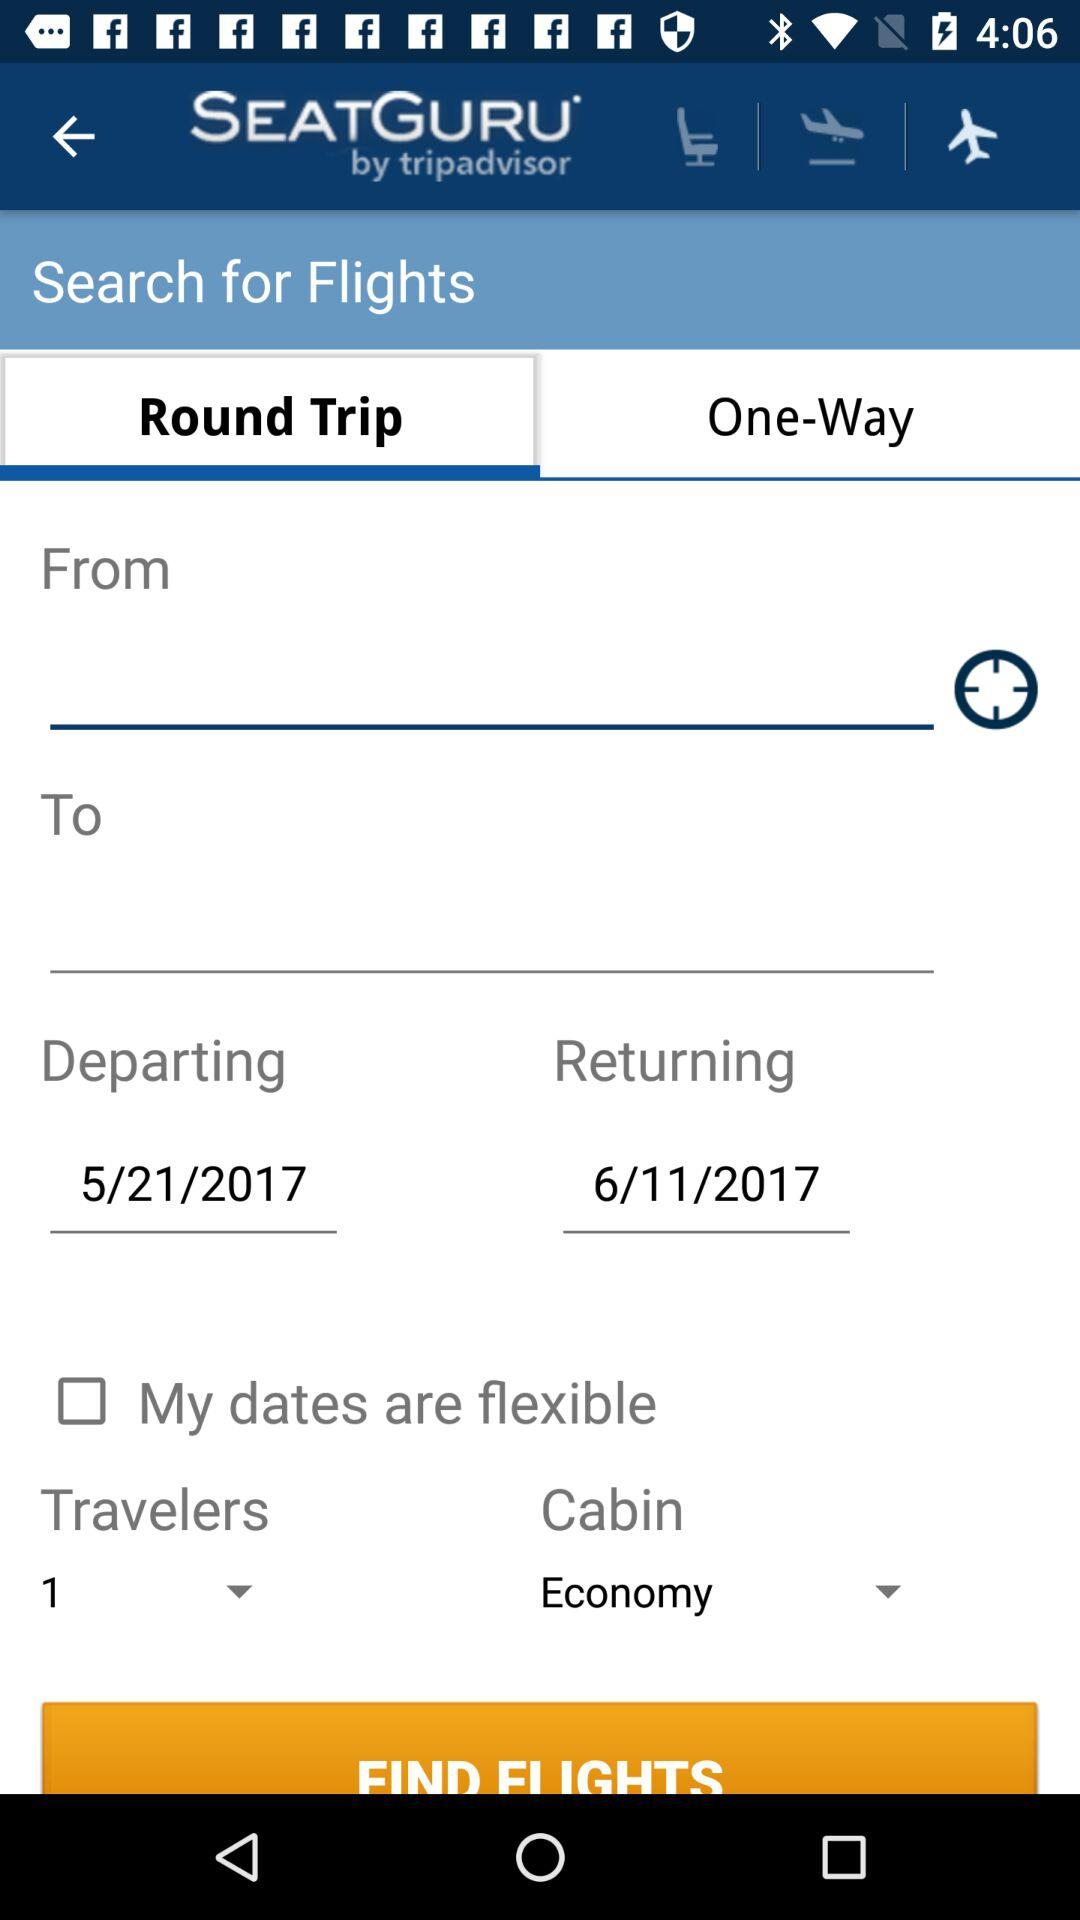How many total travelers? There is only 1 traveler. 